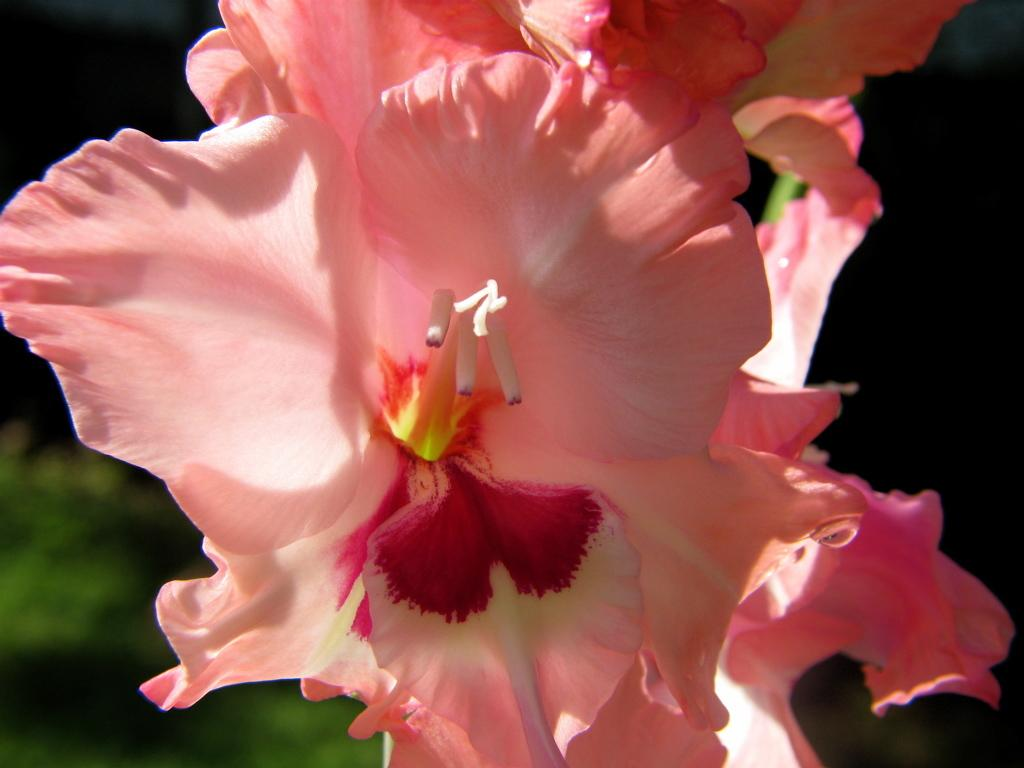What type of living organisms can be seen in the image? There are flowers in the image. Can you describe the background of the image? The background of the image is blurry. What type of pancake is being used to hold the flowers in the image? There is no pancake present in the image; the flowers are not being held by any object. 